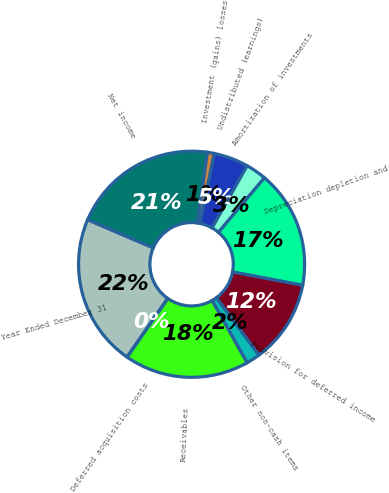Convert chart. <chart><loc_0><loc_0><loc_500><loc_500><pie_chart><fcel>Year Ended December 31<fcel>Net income<fcel>Investment (gains) losses<fcel>Undistributed (earnings)<fcel>Amortization of investments<fcel>Depreciation depletion and<fcel>Provision for deferred income<fcel>Other non-cash items<fcel>Receivables<fcel>Deferred acquisition costs<nl><fcel>21.78%<fcel>20.79%<fcel>0.99%<fcel>4.95%<fcel>2.97%<fcel>16.83%<fcel>11.88%<fcel>1.98%<fcel>17.82%<fcel>0.0%<nl></chart> 